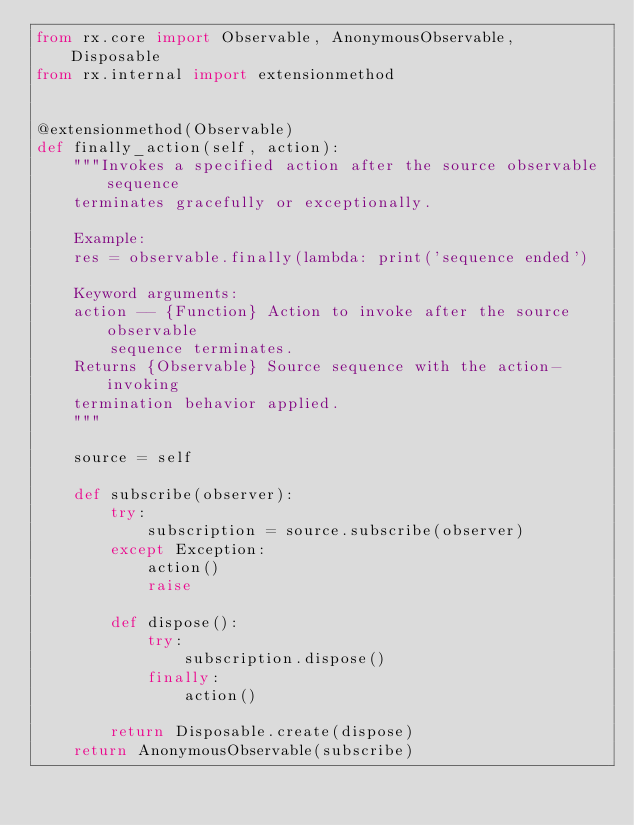<code> <loc_0><loc_0><loc_500><loc_500><_Python_>from rx.core import Observable, AnonymousObservable, Disposable
from rx.internal import extensionmethod


@extensionmethod(Observable)
def finally_action(self, action):
    """Invokes a specified action after the source observable sequence
    terminates gracefully or exceptionally.

    Example:
    res = observable.finally(lambda: print('sequence ended')

    Keyword arguments:
    action -- {Function} Action to invoke after the source observable
        sequence terminates.
    Returns {Observable} Source sequence with the action-invoking
    termination behavior applied.
    """

    source = self

    def subscribe(observer):
        try:
            subscription = source.subscribe(observer)
        except Exception:
            action()
            raise

        def dispose():
            try:
                subscription.dispose()
            finally:
                action()

        return Disposable.create(dispose)
    return AnonymousObservable(subscribe)
</code> 